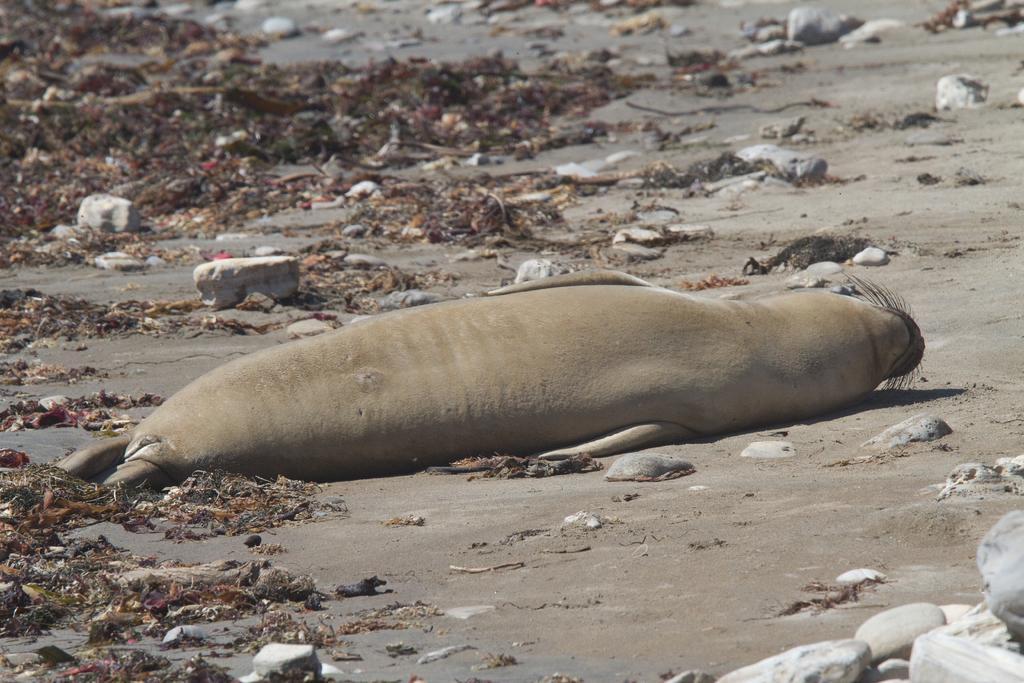How would you summarize this image in a sentence or two? In this image there is a seal sleeping in the sand. There are stones around it. On the left side top there is some waste. 